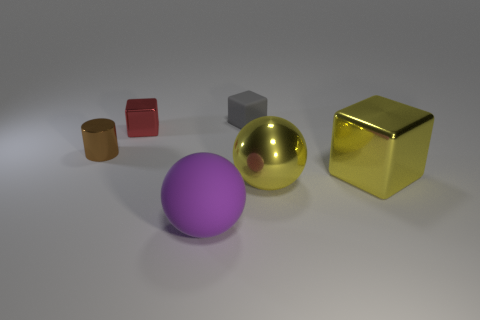Describe the lighting in the scene. The lighting in the scene is soft and diffused, providing a gentle illumination from above that casts subtle shadows beneath the objects, creating a calm and even ambiance. Does the lighting affect the colors of the objects? Yes, the soft lighting may slightly enhance the vibrancy of the objects' colors, giving them a rich and full appearance, while also highlighting the reflective properties of the metallic surfaces. 